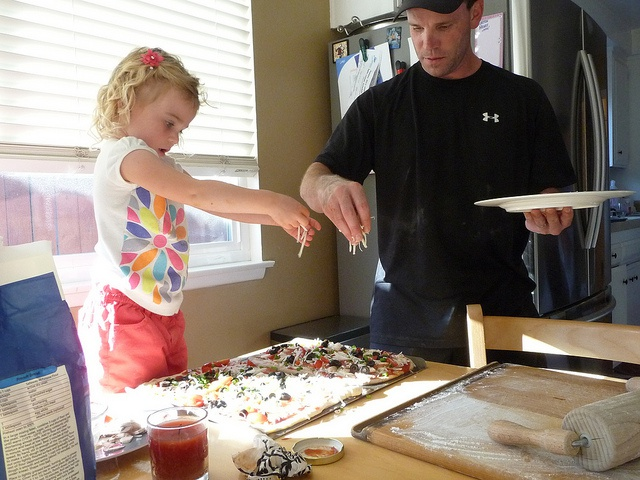Describe the objects in this image and their specific colors. I can see dining table in beige, white, tan, darkgray, and gray tones, people in beige, black, brown, and maroon tones, people in beige, white, salmon, gray, and tan tones, refrigerator in beige, black, gray, lightgray, and darkgray tones, and pizza in beige, white, darkgray, tan, and gray tones in this image. 